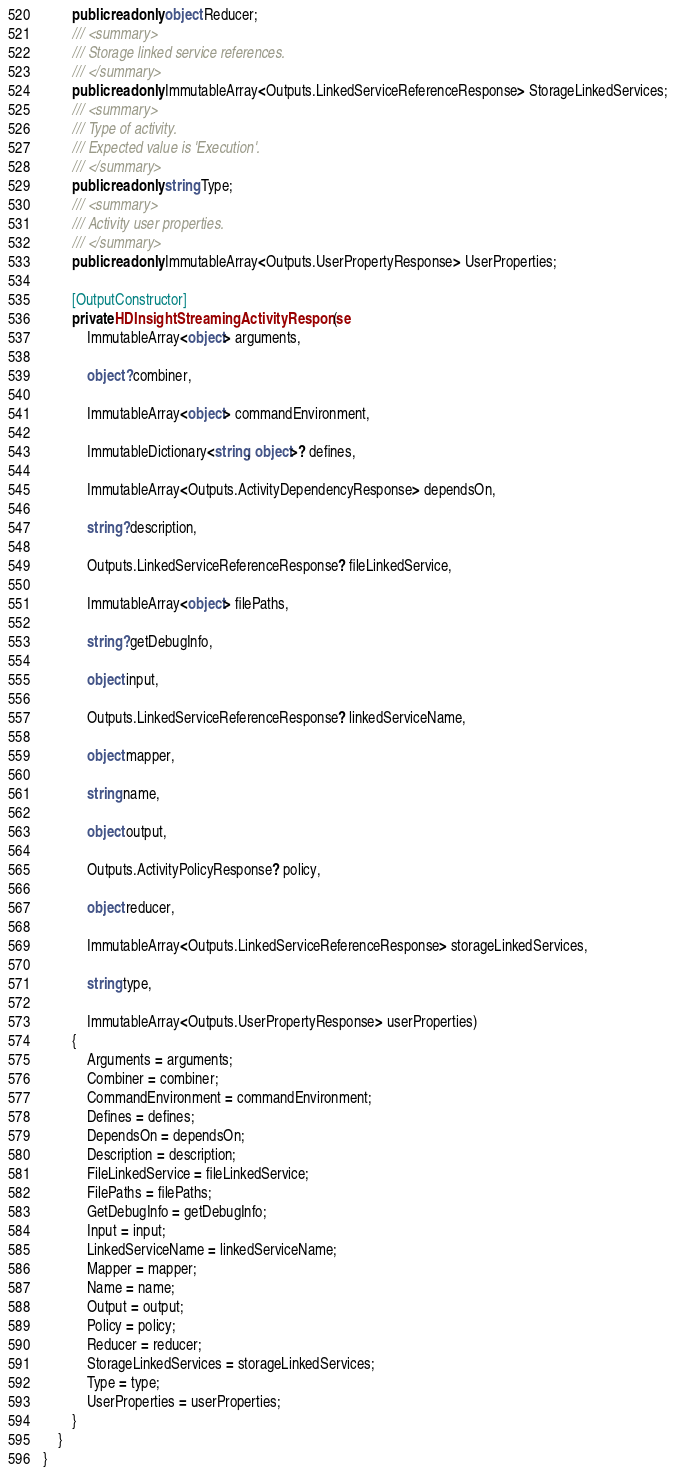<code> <loc_0><loc_0><loc_500><loc_500><_C#_>        public readonly object Reducer;
        /// <summary>
        /// Storage linked service references.
        /// </summary>
        public readonly ImmutableArray<Outputs.LinkedServiceReferenceResponse> StorageLinkedServices;
        /// <summary>
        /// Type of activity.
        /// Expected value is 'Execution'.
        /// </summary>
        public readonly string Type;
        /// <summary>
        /// Activity user properties.
        /// </summary>
        public readonly ImmutableArray<Outputs.UserPropertyResponse> UserProperties;

        [OutputConstructor]
        private HDInsightStreamingActivityResponse(
            ImmutableArray<object> arguments,

            object? combiner,

            ImmutableArray<object> commandEnvironment,

            ImmutableDictionary<string, object>? defines,

            ImmutableArray<Outputs.ActivityDependencyResponse> dependsOn,

            string? description,

            Outputs.LinkedServiceReferenceResponse? fileLinkedService,

            ImmutableArray<object> filePaths,

            string? getDebugInfo,

            object input,

            Outputs.LinkedServiceReferenceResponse? linkedServiceName,

            object mapper,

            string name,

            object output,

            Outputs.ActivityPolicyResponse? policy,

            object reducer,

            ImmutableArray<Outputs.LinkedServiceReferenceResponse> storageLinkedServices,

            string type,

            ImmutableArray<Outputs.UserPropertyResponse> userProperties)
        {
            Arguments = arguments;
            Combiner = combiner;
            CommandEnvironment = commandEnvironment;
            Defines = defines;
            DependsOn = dependsOn;
            Description = description;
            FileLinkedService = fileLinkedService;
            FilePaths = filePaths;
            GetDebugInfo = getDebugInfo;
            Input = input;
            LinkedServiceName = linkedServiceName;
            Mapper = mapper;
            Name = name;
            Output = output;
            Policy = policy;
            Reducer = reducer;
            StorageLinkedServices = storageLinkedServices;
            Type = type;
            UserProperties = userProperties;
        }
    }
}
</code> 